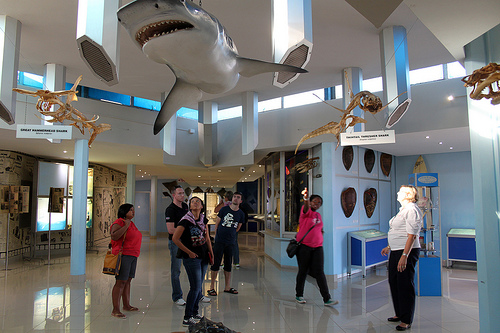<image>
Is there a women to the left of the man? Yes. From this viewpoint, the women is positioned to the left side relative to the man. Is the shark next to the dinosaur? Yes. The shark is positioned adjacent to the dinosaur, located nearby in the same general area. 